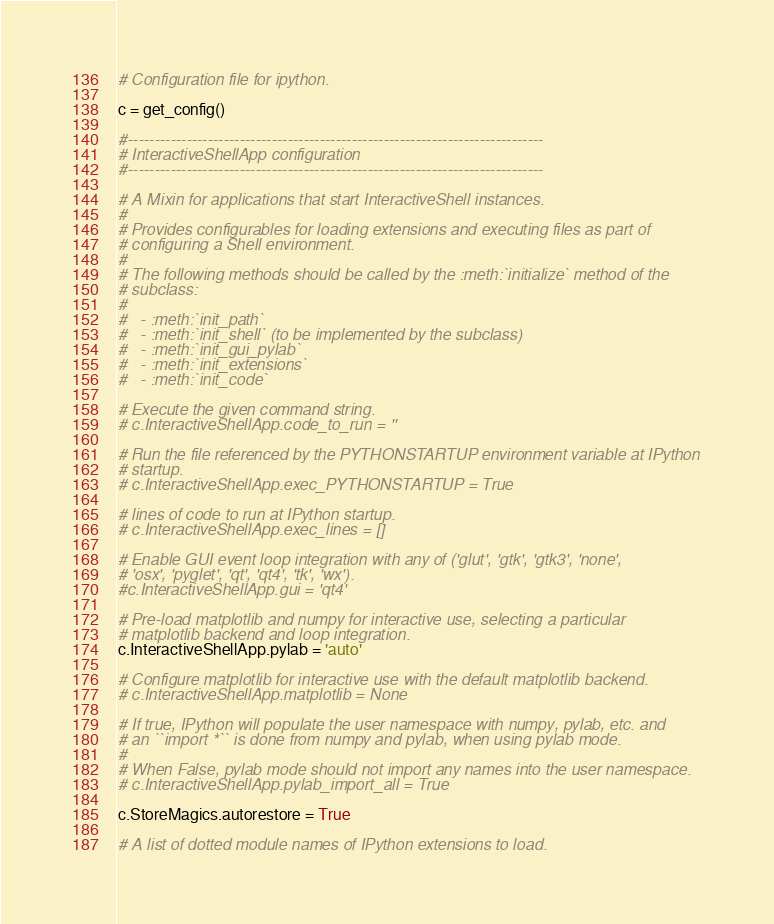Convert code to text. <code><loc_0><loc_0><loc_500><loc_500><_Python_># Configuration file for ipython.

c = get_config()

#------------------------------------------------------------------------------
# InteractiveShellApp configuration
#------------------------------------------------------------------------------

# A Mixin for applications that start InteractiveShell instances.
#
# Provides configurables for loading extensions and executing files as part of
# configuring a Shell environment.
#
# The following methods should be called by the :meth:`initialize` method of the
# subclass:
#
#   - :meth:`init_path`
#   - :meth:`init_shell` (to be implemented by the subclass)
#   - :meth:`init_gui_pylab`
#   - :meth:`init_extensions`
#   - :meth:`init_code`

# Execute the given command string.
# c.InteractiveShellApp.code_to_run = ''

# Run the file referenced by the PYTHONSTARTUP environment variable at IPython
# startup.
# c.InteractiveShellApp.exec_PYTHONSTARTUP = True

# lines of code to run at IPython startup.
# c.InteractiveShellApp.exec_lines = []

# Enable GUI event loop integration with any of ('glut', 'gtk', 'gtk3', 'none',
# 'osx', 'pyglet', 'qt', 'qt4', 'tk', 'wx').
#c.InteractiveShellApp.gui = 'qt4'

# Pre-load matplotlib and numpy for interactive use, selecting a particular
# matplotlib backend and loop integration.
c.InteractiveShellApp.pylab = 'auto'

# Configure matplotlib for interactive use with the default matplotlib backend.
# c.InteractiveShellApp.matplotlib = None

# If true, IPython will populate the user namespace with numpy, pylab, etc. and
# an ``import *`` is done from numpy and pylab, when using pylab mode.
#
# When False, pylab mode should not import any names into the user namespace.
# c.InteractiveShellApp.pylab_import_all = True

c.StoreMagics.autorestore = True

# A list of dotted module names of IPython extensions to load.</code> 